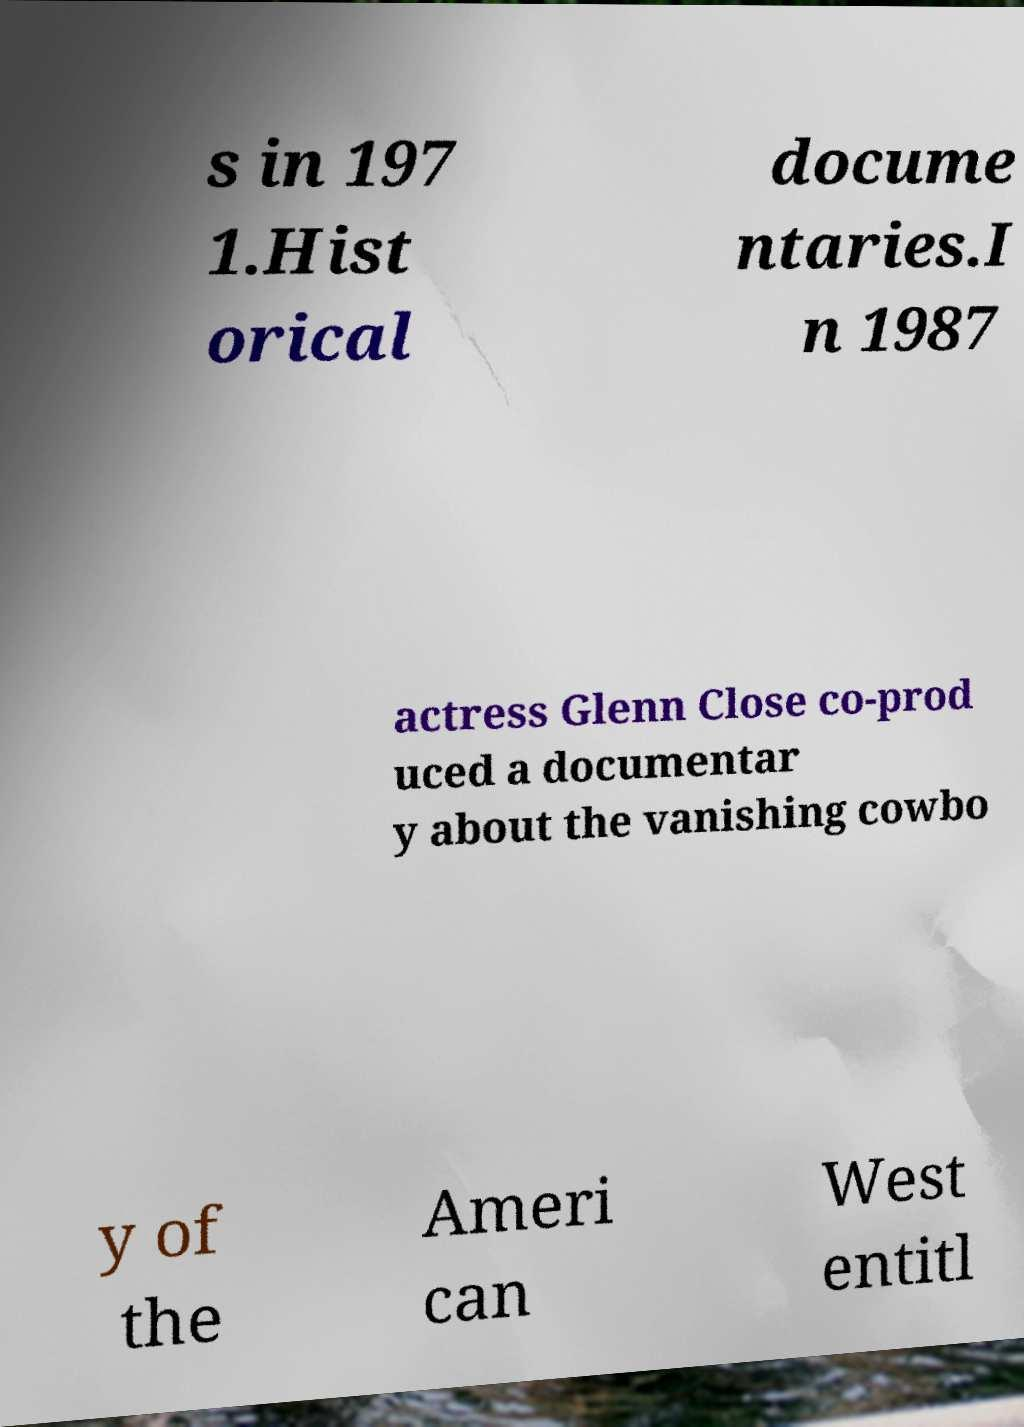What messages or text are displayed in this image? I need them in a readable, typed format. s in 197 1.Hist orical docume ntaries.I n 1987 actress Glenn Close co-prod uced a documentar y about the vanishing cowbo y of the Ameri can West entitl 